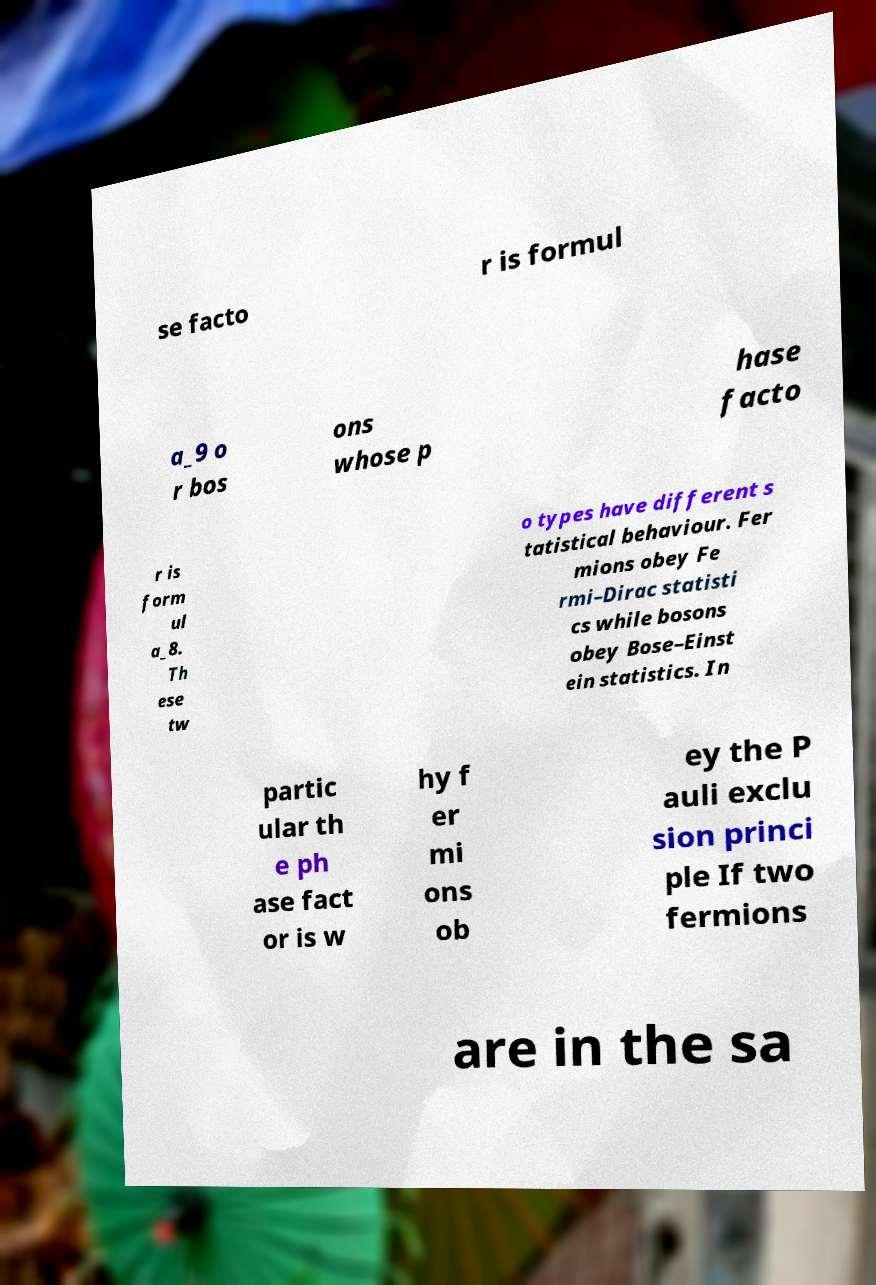Can you read and provide the text displayed in the image?This photo seems to have some interesting text. Can you extract and type it out for me? se facto r is formul a_9 o r bos ons whose p hase facto r is form ul a_8. Th ese tw o types have different s tatistical behaviour. Fer mions obey Fe rmi–Dirac statisti cs while bosons obey Bose–Einst ein statistics. In partic ular th e ph ase fact or is w hy f er mi ons ob ey the P auli exclu sion princi ple If two fermions are in the sa 